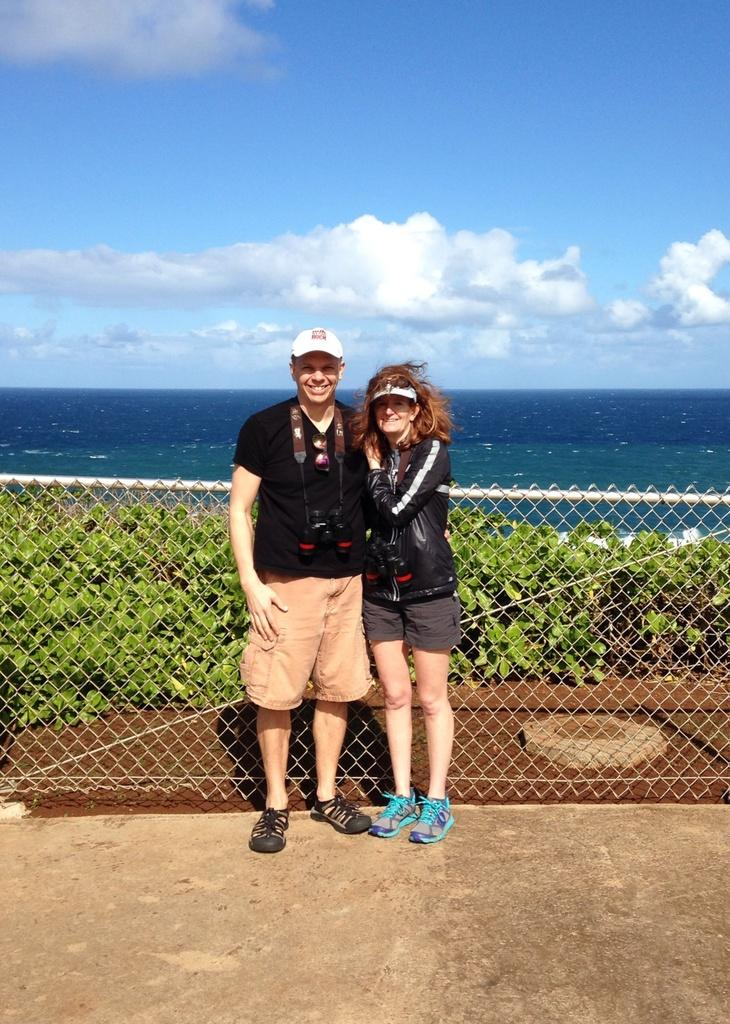Who are the people in the image? There is a man and a woman in the image. What are the people wearing on their heads? Both the man and the woman are wearing caps. What can be seen in the background of the image? There is a metal fence and water visible in the image. How would you describe the sky in the image? The sky is blue and cloudy. What type of vegetation is present in the image? There are plants in the image. What list of ideas can be seen in the image? There is no list of ideas present in the image. How does the man's hearing affect the conversation in the image? There is no conversation depicted in the image, and we cannot determine the man's hearing abilities from the image alone. 